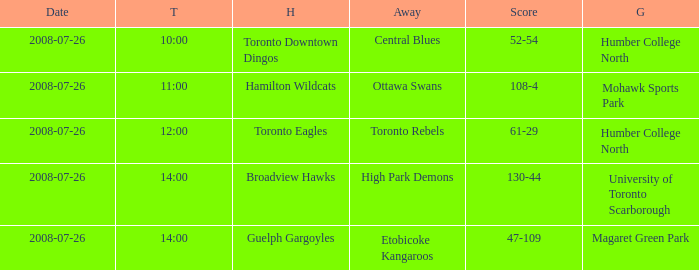With the Ground of Humber College North at 12:00, what was the Away? Toronto Rebels. 